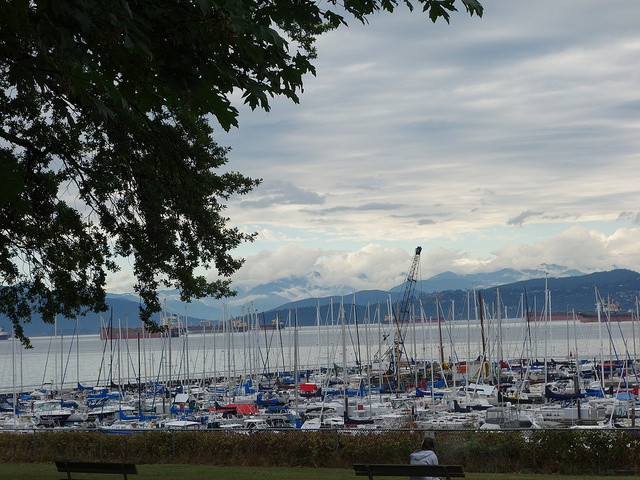Describe the objects in this image and their specific colors. I can see boat in black, gray, darkgray, and navy tones, boat in black and gray tones, bench in black and gray tones, bench in black tones, and boat in black, gray, blue, and darkgray tones in this image. 